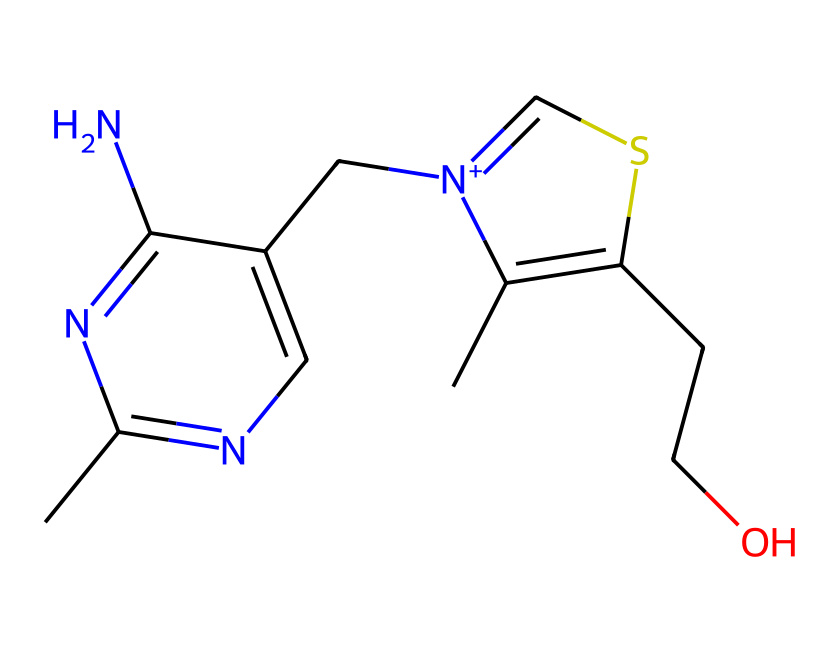What is the molecular formula of this compound? The molecular formula can be derived by counting the atoms represented in the SMILES notation. In the given SMILES, there are 12 carbon (C), 15 hydrogen (H), 4 nitrogen (N), and 1 sulfur (S) atom. Therefore, the molecular formula is constructed as C12H15N4OS.
Answer: C12H15N4OS How many nitrogen atoms are present in the structure? By examining the SMILES notation, there are four nitrogen atoms (indicated by the 'N' symbols).
Answer: 4 What type of bonding is likely to be present in this compound? The chemical contains both single and double bonds, inferred from the arrangement and connectivity in the SMILES notation. The presence of aromatic groups also suggests resonance stabilization due to delocalized pi electrons.
Answer: single and double bonds Which functional group is associated with the sulfur in this compound? The sulfur in this compound is part of a thiazole ring structure, which typically features a sulfur atom bonded to a carbon atom. This indicates it's involved in heterocyclic chemistry, particularly organosulfur compounds.
Answer: thiazole What element differentiates thiamine from other members of its vitamin B complex? Thiamine is distinct due to its sulfur content, which is not present in other B vitamins. The structure reveals a sulfur atom integral to its thiazole ring.
Answer: sulfur Is this compound water-soluble? Based on the presence of hydroxyl (–OH) groups in the structure, thiamine can engage in hydrogen bonding with water, which suggests solubility in polar solvents like water.
Answer: yes 